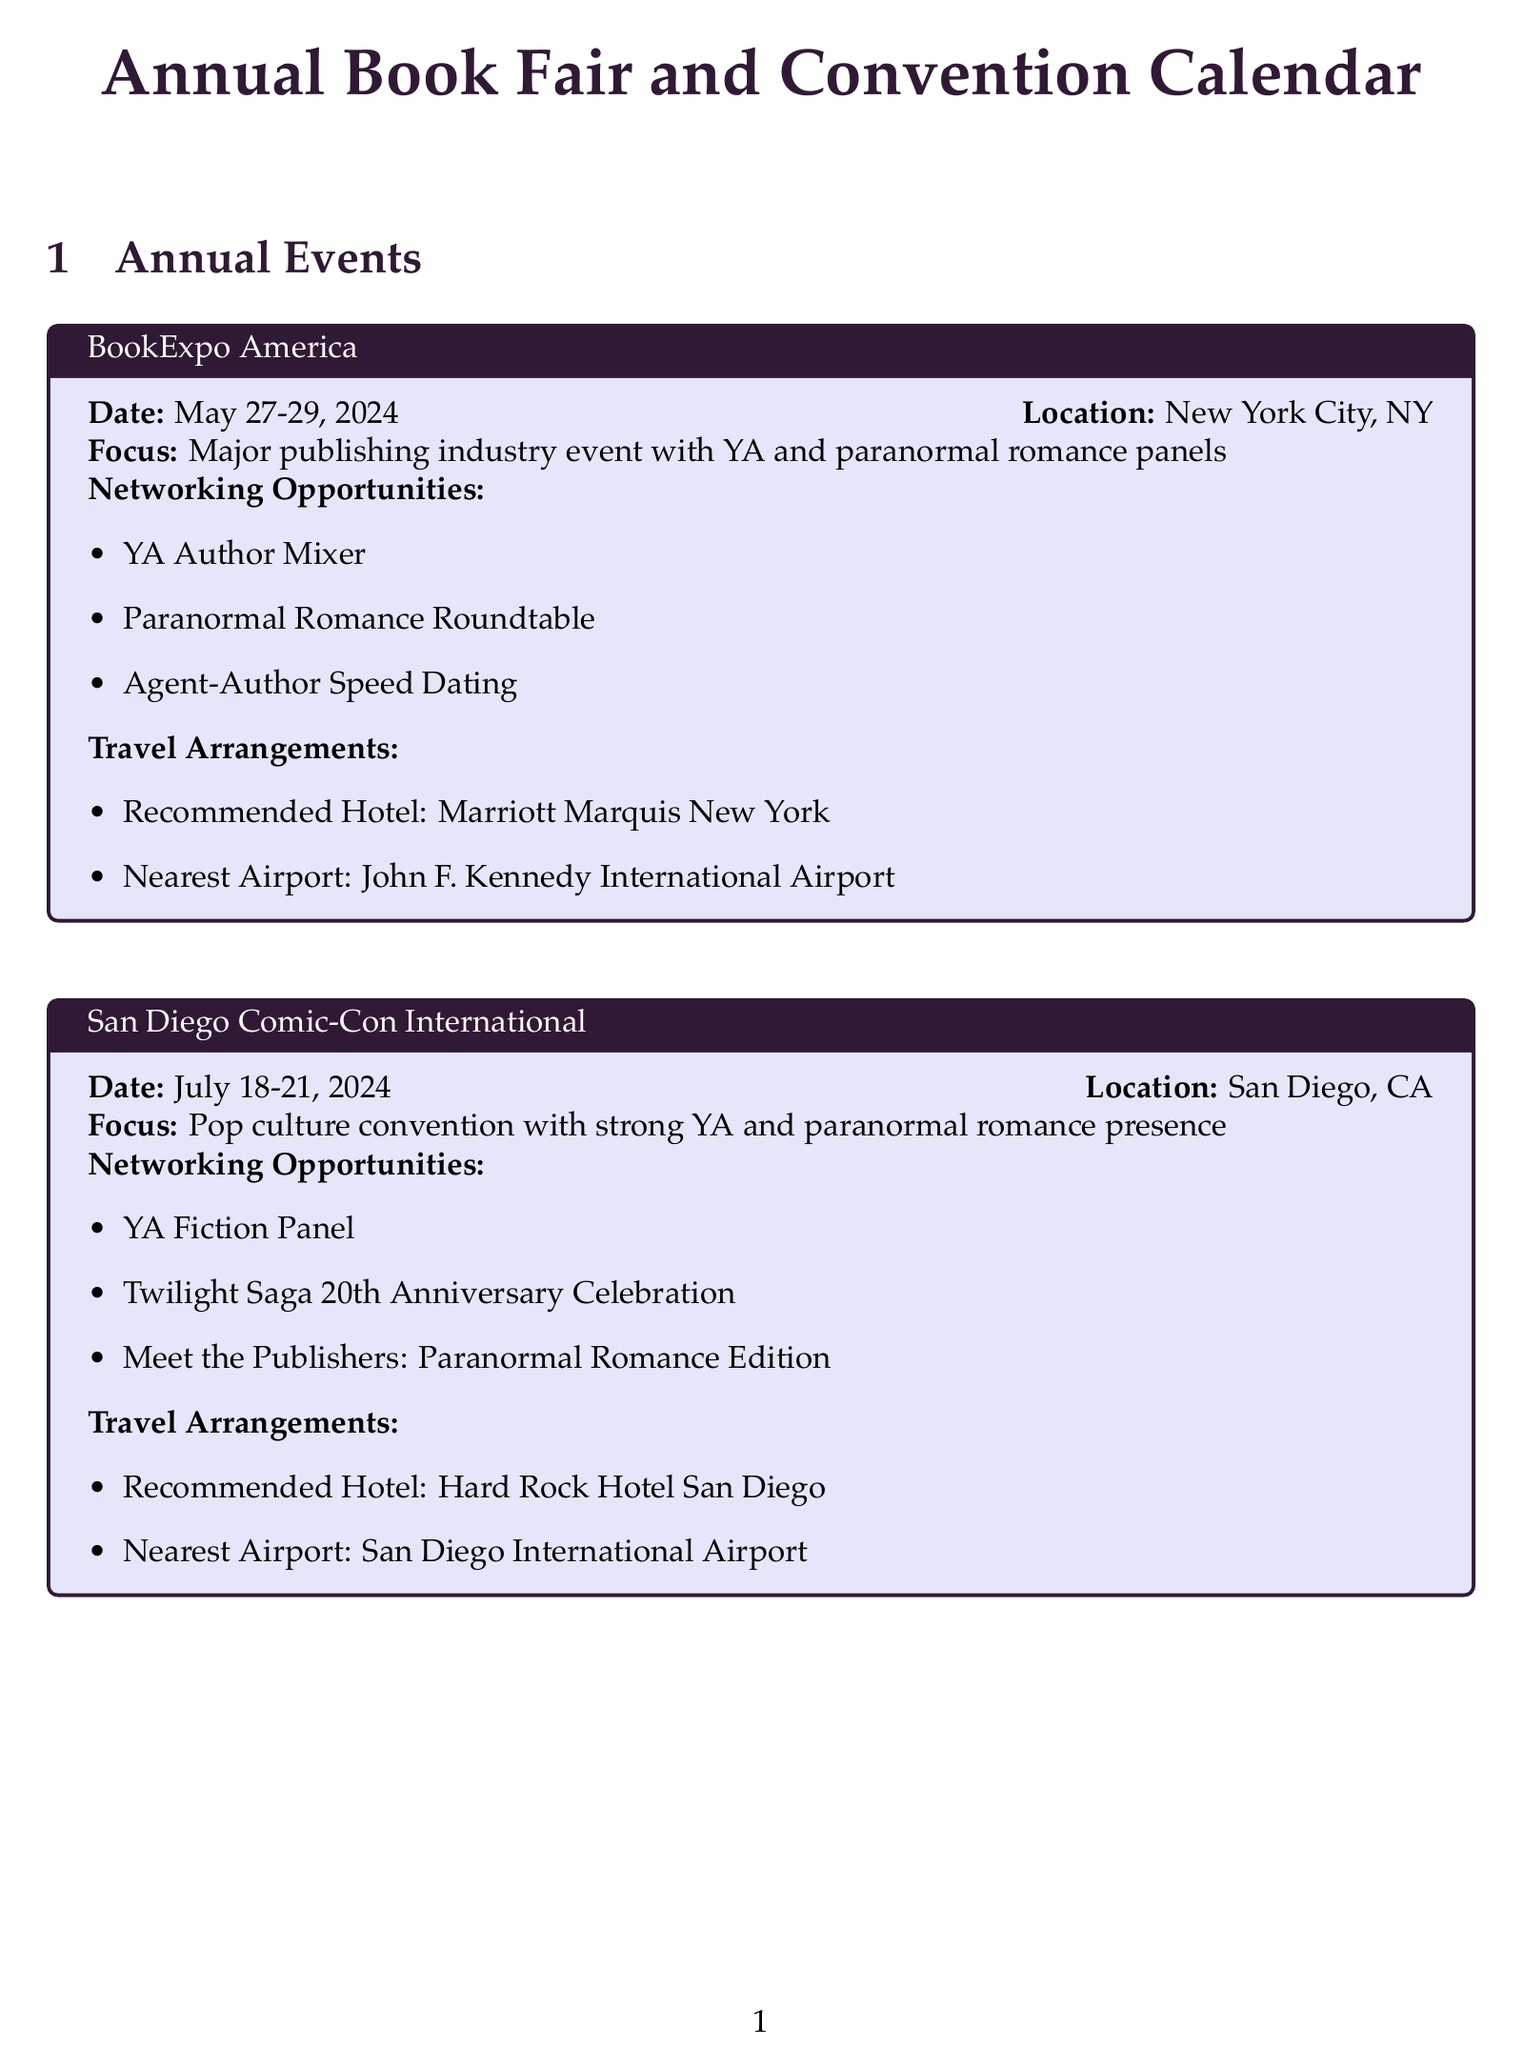What are the dates for BookExpo America? The document states that BookExpo America is scheduled for May 27-29, 2024.
Answer: May 27-29, 2024 What is the focus of San Diego Comic-Con International? The focus listed for San Diego Comic-Con International is "Pop culture convention with strong YA and paranormal romance presence."
Answer: Pop culture convention with strong YA and paranormal romance presence What are the networking opportunities at YALLFest? The document lists the networking opportunities at YALLFest, which include "Agent One-on-Ones," "YA Paranormal Romance Panel," and "Publishing Industry Mixer."
Answer: Agent One-on-Ones, YA Paranormal Romance Panel, Publishing Industry Mixer Which hotel is recommended for the Frankfurt Book Fair? The document indicates that the recommended hotel for the Frankfurt Book Fair is the Maritim Hotel Frankfurt.
Answer: Maritim Hotel Frankfurt What is the frequency of the Virtual YA Book Club? The document mentions that the Virtual YA Book Club occurs on the first Thursday of every month.
Answer: First Thursday of every month How many networking opportunities are provided at the Romance Writers of America Annual Conference? The document lists three networking opportunities related to the Romance Writers of America Annual Conference.
Answer: Three Which platform is used for the Paranormal Romance Writing Workshop? The document states that the Paranormal Romance Writing Workshop is held on Google Meet.
Answer: Google Meet What is the nearest airport to the recommended hotel for YALLFest? The document specifies that the nearest airport to the Francis Marion Hotel is Charleston International Airport.
Answer: Charleston International Airport What subscription type does Publishers Weekly offer? The document describes Publishers Weekly as a weekly magazine and daily online updates.
Answer: Weekly magazine and daily online updates 